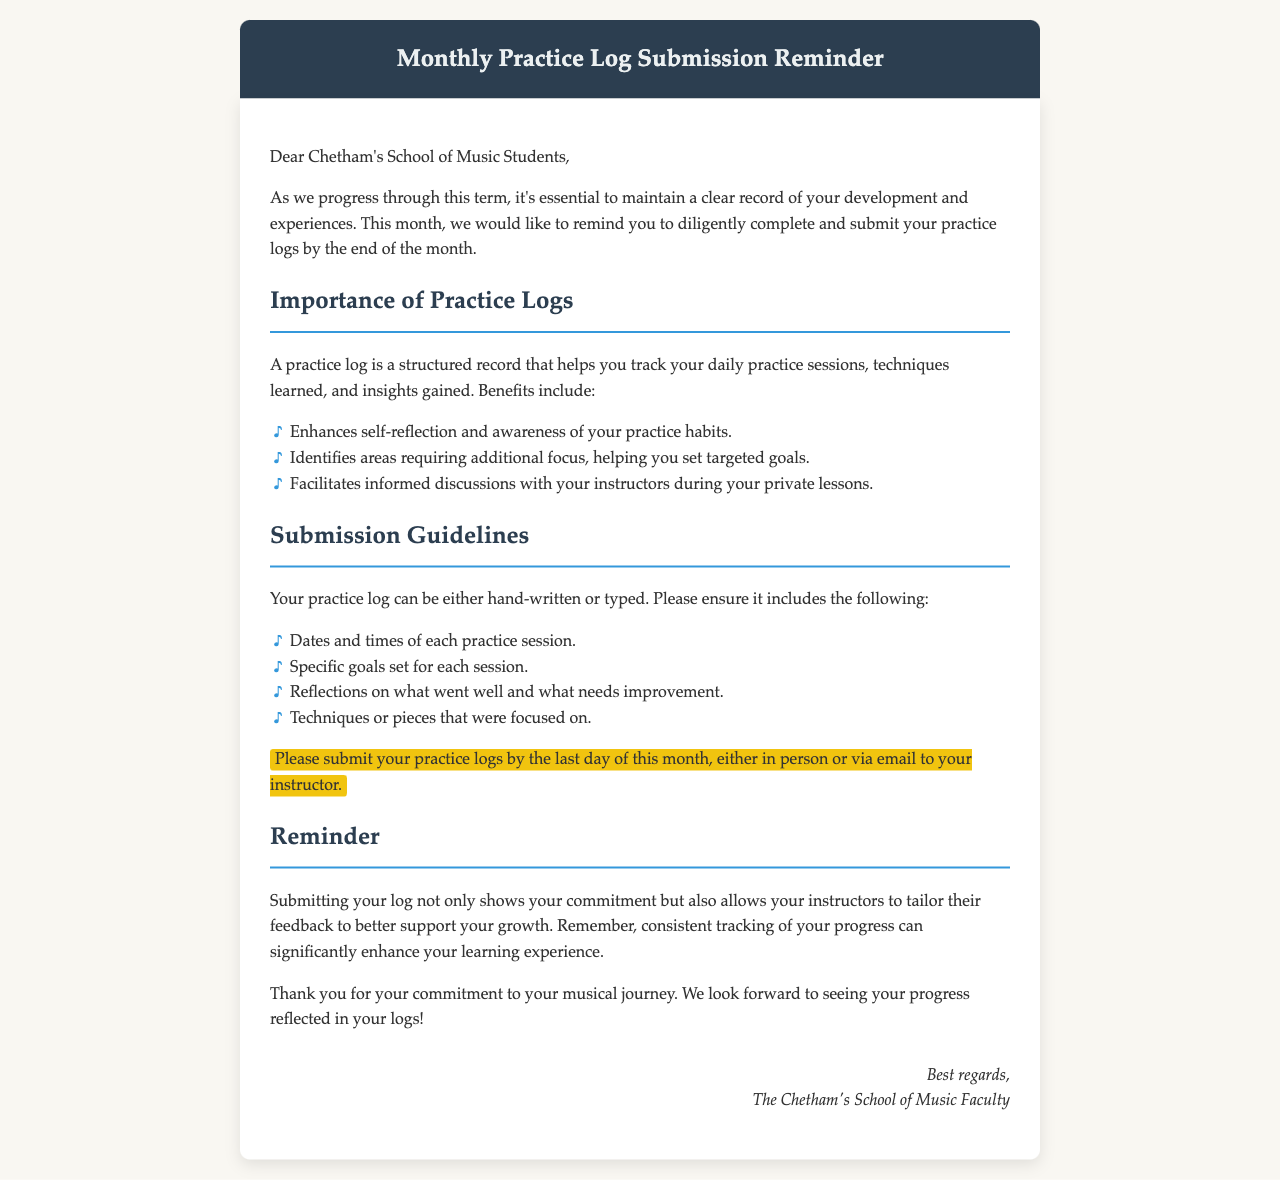What is the deadline for practice log submission? The document states that practice logs should be submitted by the last day of the month.
Answer: last day of the month What should be included in the practice log? The document lists specific items that should be included, such as dates, goals, reflections, and techniques.
Answer: Dates, goals, reflections, techniques What is the main purpose of a practice log? The document explains that a practice log helps track practice sessions and insights gained, enhancing self-reflection.
Answer: track practice sessions and insights Who should practice logs be submitted to? The document mentions that practice logs can be submitted either in person or via email to instructors.
Answer: instructors What color is the header of the email? The document describes the header color as a shade of dark blue.
Answer: dark blue How does submitting the log benefit students? The document states that submitting the log allows instructors to tailor feedback and supports student growth.
Answer: tailored feedback What type of document is this? The document is categorized as a reminder email addressed to students.
Answer: reminder email What benefits does a practice log provide? The document outlines benefits such as enhancing self-reflection and identifying focus areas.
Answer: enhancing self-reflection What tone does the concluding message convey? The document conveys a tone of encouragement and appreciation for the students' commitment.
Answer: encouragement 